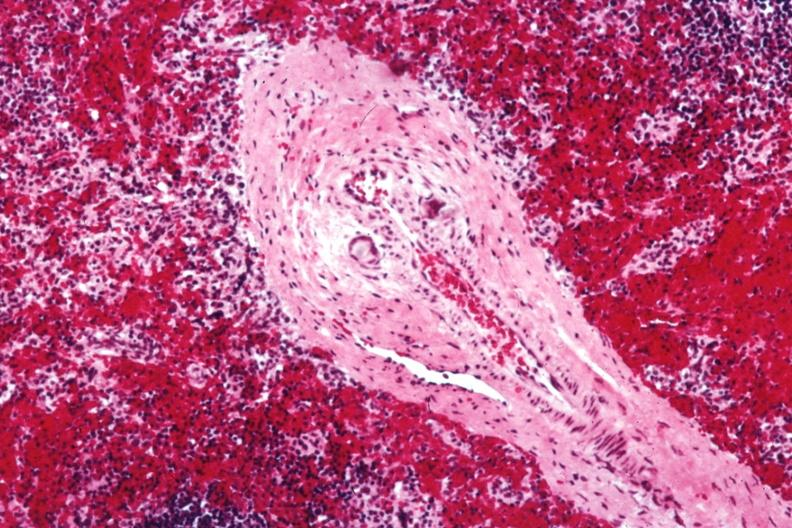what is present?
Answer the question using a single word or phrase. Spleen 